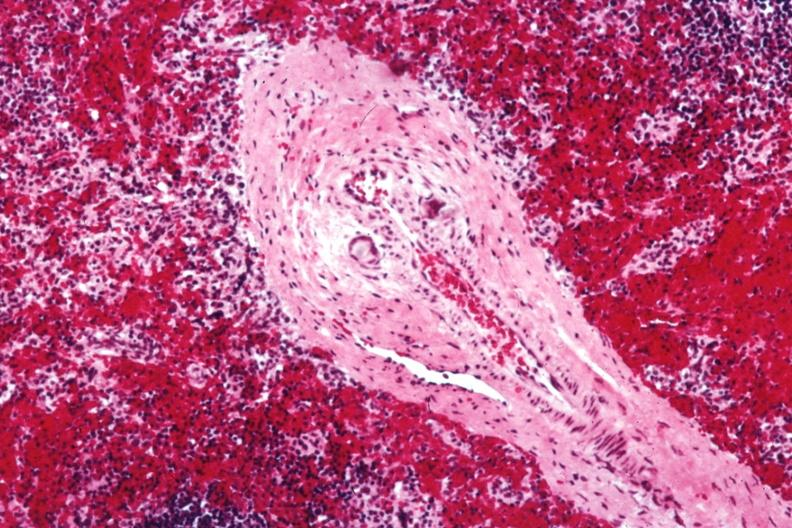what is present?
Answer the question using a single word or phrase. Spleen 